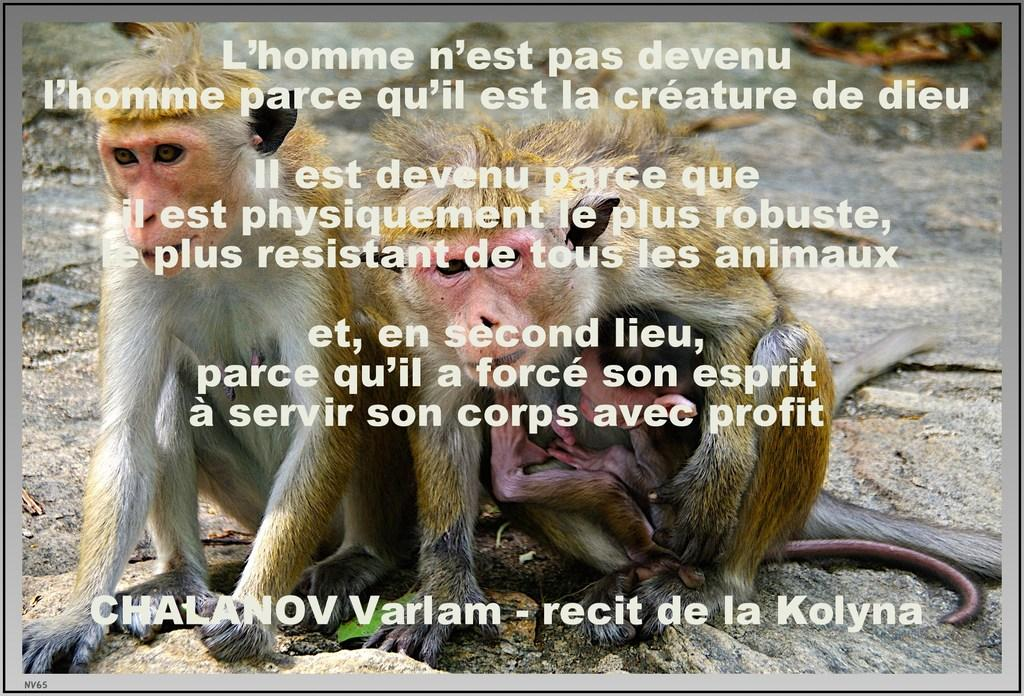How many monkeys are in the image? There are two monkeys in the image. Where are the monkeys located in the image? The monkeys are sitting in the front. What can be found written on the image? There is some matter written on the image. What type of brass instrument is being played by the monkeys in the image? There is no brass instrument present in the image; it only features two monkeys sitting in the front. 